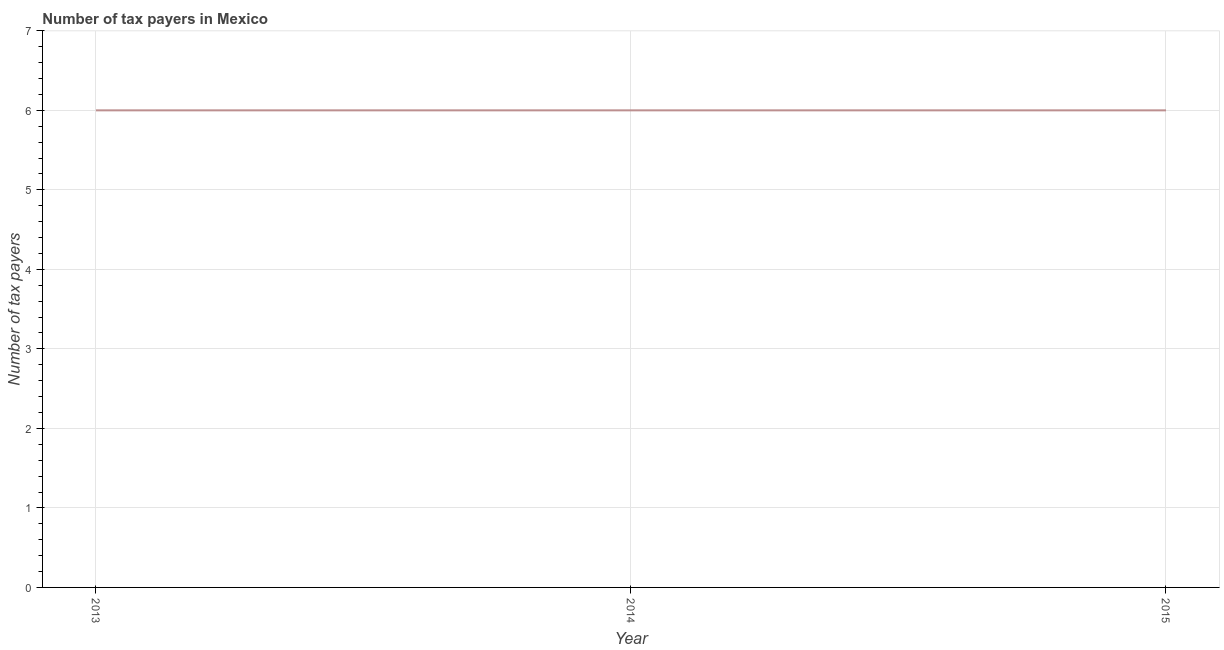What is the number of tax payers in 2015?
Keep it short and to the point. 6. Across all years, what is the maximum number of tax payers?
Offer a terse response. 6. Across all years, what is the minimum number of tax payers?
Offer a terse response. 6. What is the sum of the number of tax payers?
Your response must be concise. 18. What is the difference between the number of tax payers in 2013 and 2014?
Your answer should be compact. 0. What is the median number of tax payers?
Your answer should be compact. 6. In how many years, is the number of tax payers greater than 3.2 ?
Provide a short and direct response. 3. Do a majority of the years between 2013 and 2014 (inclusive) have number of tax payers greater than 0.4 ?
Keep it short and to the point. Yes. Is the difference between the number of tax payers in 2013 and 2014 greater than the difference between any two years?
Your answer should be compact. Yes. Is the sum of the number of tax payers in 2013 and 2014 greater than the maximum number of tax payers across all years?
Provide a short and direct response. Yes. How many years are there in the graph?
Your answer should be very brief. 3. What is the difference between two consecutive major ticks on the Y-axis?
Offer a terse response. 1. Are the values on the major ticks of Y-axis written in scientific E-notation?
Your answer should be very brief. No. Does the graph contain grids?
Offer a terse response. Yes. What is the title of the graph?
Keep it short and to the point. Number of tax payers in Mexico. What is the label or title of the Y-axis?
Make the answer very short. Number of tax payers. What is the Number of tax payers in 2013?
Keep it short and to the point. 6. What is the Number of tax payers of 2014?
Provide a short and direct response. 6. What is the Number of tax payers in 2015?
Provide a succinct answer. 6. What is the ratio of the Number of tax payers in 2013 to that in 2014?
Provide a short and direct response. 1. What is the ratio of the Number of tax payers in 2014 to that in 2015?
Keep it short and to the point. 1. 